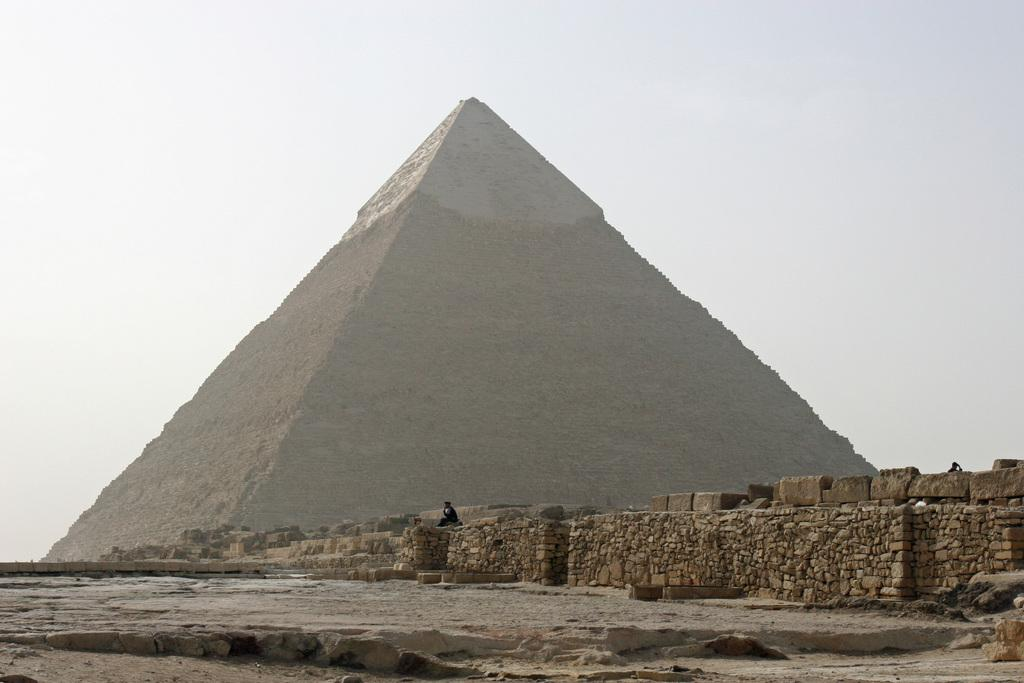What is the main structure in the image? There is a pyramid in the image. What type of material is used for the wall in the image? There is a stone wall in the image. How many people are present in the image? There are two people in the image. What can be seen in the background of the image? The sky is visible in the image. What are the colors of the sky in the image? The sky has a white and blue color in the image. Where are the plants located in the image? There are no plants visible in the image. What type of glass is being used by the boy in the image? There is no boy or glass present in the image. 